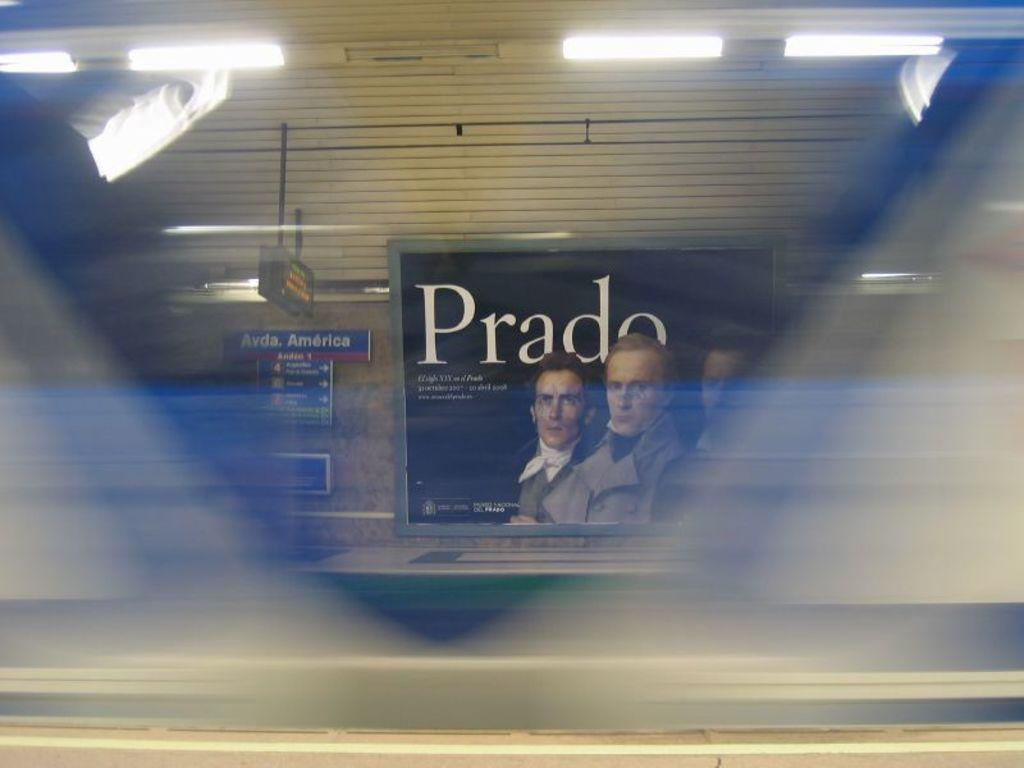What is on the wall in the image? There is a board on the wall in the image. What can be seen on the board? The board contains images of three persons and text. Where are the lights located in the image? The lights are in the top left and top right of the image. How many geese are flying in the sky in the image? There are no geese or sky visible in the image; it only shows a board on the wall with images of three persons and text, along with lights in the top left and top right. 